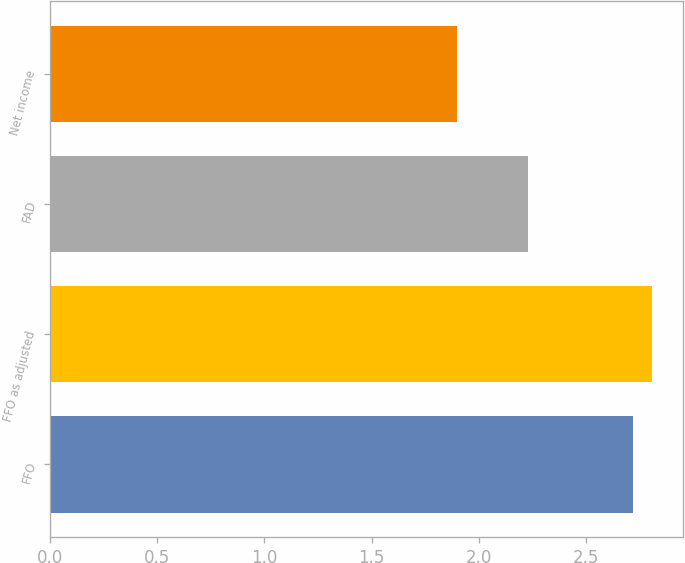<chart> <loc_0><loc_0><loc_500><loc_500><bar_chart><fcel>FFO<fcel>FFO as adjusted<fcel>FAD<fcel>Net income<nl><fcel>2.72<fcel>2.81<fcel>2.23<fcel>1.9<nl></chart> 